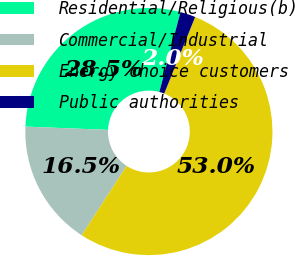Convert chart. <chart><loc_0><loc_0><loc_500><loc_500><pie_chart><fcel>Residential/Religious(b)<fcel>Commercial/Industrial<fcel>Energy choice customers<fcel>Public authorities<nl><fcel>28.48%<fcel>16.49%<fcel>53.04%<fcel>1.99%<nl></chart> 